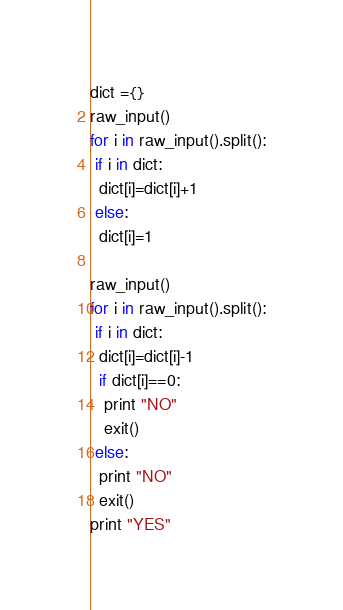Convert code to text. <code><loc_0><loc_0><loc_500><loc_500><_Python_>dict ={}
raw_input()
for i in raw_input().split():
 if i in dict:
  dict[i]=dict[i]+1
 else:
  dict[i]=1

raw_input()
for i in raw_input().split():
 if i in dict:
  dict[i]=dict[i]-1
  if dict[i]==0:
   print "NO"
   exit()
 else:
  print "NO"
  exit()
print "YES"</code> 